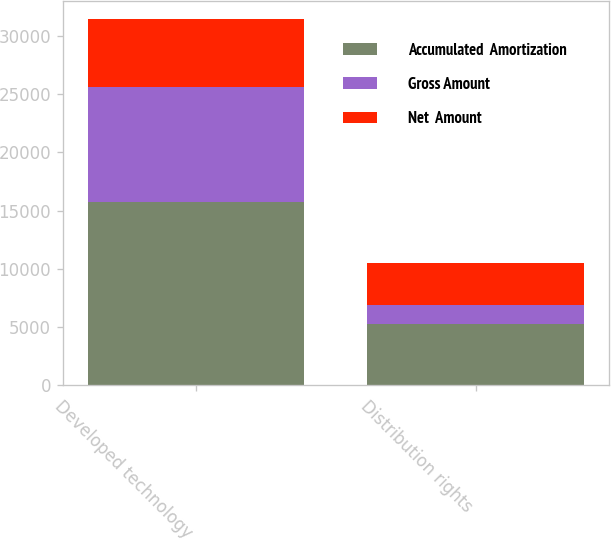<chart> <loc_0><loc_0><loc_500><loc_500><stacked_bar_chart><ecel><fcel>Developed technology<fcel>Distribution rights<nl><fcel>Accumulated  Amortization<fcel>15729<fcel>5236<nl><fcel>Gross Amount<fcel>9864<fcel>1612<nl><fcel>Net  Amount<fcel>5865<fcel>3624<nl></chart> 